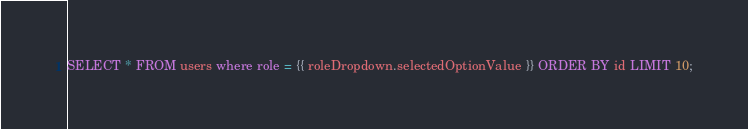<code> <loc_0><loc_0><loc_500><loc_500><_SQL_>SELECT * FROM users where role = {{ roleDropdown.selectedOptionValue }} ORDER BY id LIMIT 10;</code> 